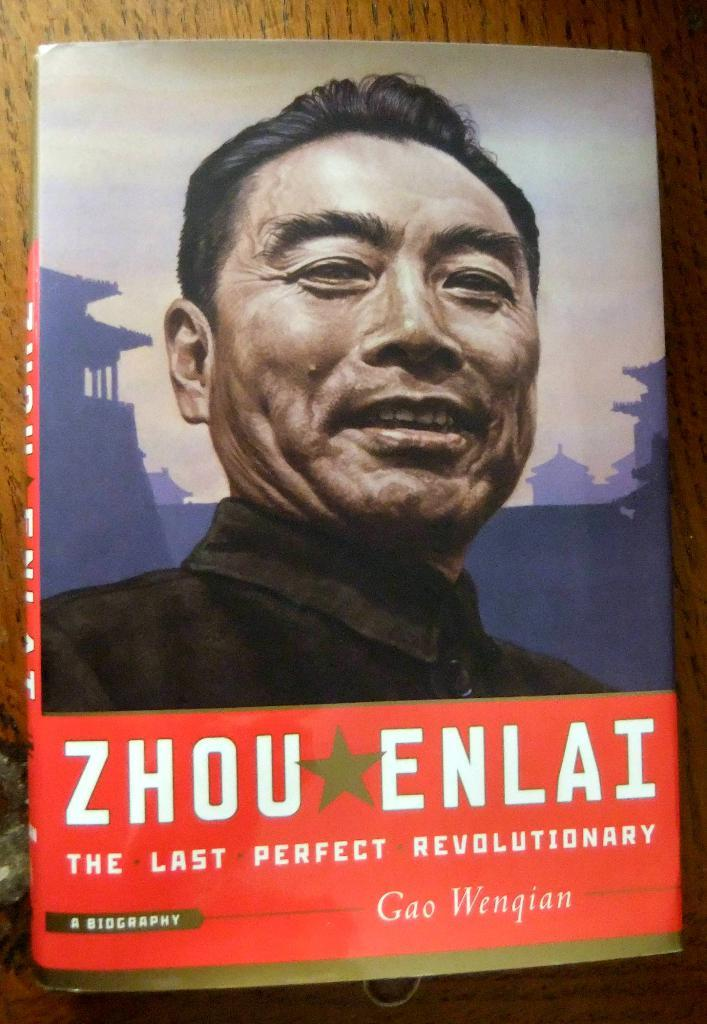What object can be seen in the image? There is a book in the image. Where is the book located? The book is placed on a table. How many legs can be seen on the book in the image? Books do not have legs, so there are no legs visible on the book in the image. 